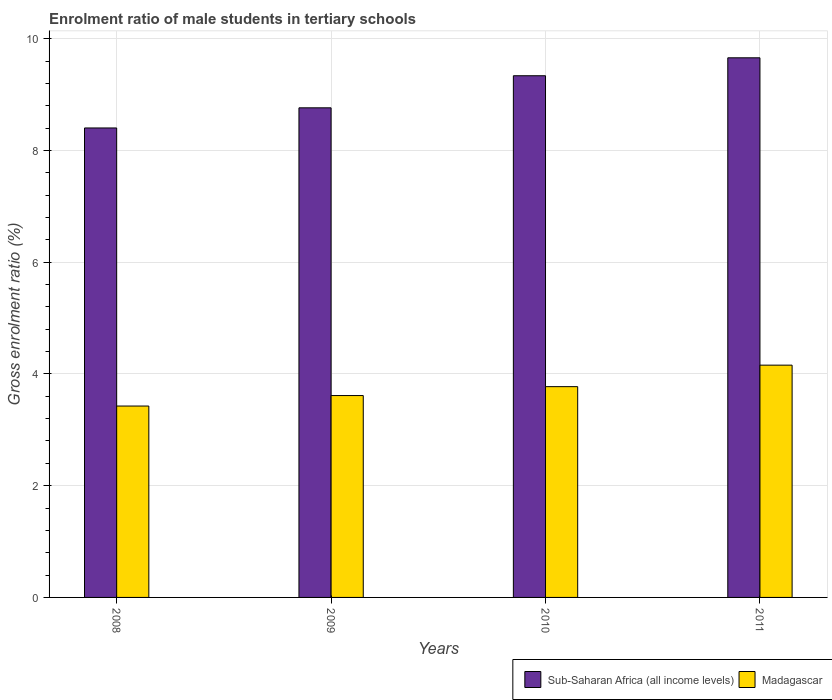How many groups of bars are there?
Your response must be concise. 4. Are the number of bars per tick equal to the number of legend labels?
Your answer should be compact. Yes. How many bars are there on the 1st tick from the right?
Your answer should be very brief. 2. What is the label of the 3rd group of bars from the left?
Keep it short and to the point. 2010. What is the enrolment ratio of male students in tertiary schools in Sub-Saharan Africa (all income levels) in 2009?
Provide a succinct answer. 8.76. Across all years, what is the maximum enrolment ratio of male students in tertiary schools in Sub-Saharan Africa (all income levels)?
Give a very brief answer. 9.66. Across all years, what is the minimum enrolment ratio of male students in tertiary schools in Madagascar?
Provide a short and direct response. 3.43. What is the total enrolment ratio of male students in tertiary schools in Sub-Saharan Africa (all income levels) in the graph?
Your answer should be compact. 36.16. What is the difference between the enrolment ratio of male students in tertiary schools in Madagascar in 2008 and that in 2009?
Ensure brevity in your answer.  -0.19. What is the difference between the enrolment ratio of male students in tertiary schools in Madagascar in 2008 and the enrolment ratio of male students in tertiary schools in Sub-Saharan Africa (all income levels) in 2009?
Your response must be concise. -5.34. What is the average enrolment ratio of male students in tertiary schools in Sub-Saharan Africa (all income levels) per year?
Ensure brevity in your answer.  9.04. In the year 2009, what is the difference between the enrolment ratio of male students in tertiary schools in Sub-Saharan Africa (all income levels) and enrolment ratio of male students in tertiary schools in Madagascar?
Your response must be concise. 5.15. In how many years, is the enrolment ratio of male students in tertiary schools in Madagascar greater than 2 %?
Ensure brevity in your answer.  4. What is the ratio of the enrolment ratio of male students in tertiary schools in Sub-Saharan Africa (all income levels) in 2009 to that in 2010?
Make the answer very short. 0.94. Is the enrolment ratio of male students in tertiary schools in Madagascar in 2008 less than that in 2011?
Give a very brief answer. Yes. What is the difference between the highest and the second highest enrolment ratio of male students in tertiary schools in Madagascar?
Provide a succinct answer. 0.38. What is the difference between the highest and the lowest enrolment ratio of male students in tertiary schools in Madagascar?
Provide a succinct answer. 0.73. In how many years, is the enrolment ratio of male students in tertiary schools in Sub-Saharan Africa (all income levels) greater than the average enrolment ratio of male students in tertiary schools in Sub-Saharan Africa (all income levels) taken over all years?
Provide a succinct answer. 2. What does the 2nd bar from the left in 2011 represents?
Ensure brevity in your answer.  Madagascar. What does the 2nd bar from the right in 2011 represents?
Your answer should be very brief. Sub-Saharan Africa (all income levels). How many years are there in the graph?
Your answer should be compact. 4. What is the difference between two consecutive major ticks on the Y-axis?
Ensure brevity in your answer.  2. Are the values on the major ticks of Y-axis written in scientific E-notation?
Keep it short and to the point. No. Does the graph contain any zero values?
Keep it short and to the point. No. How are the legend labels stacked?
Ensure brevity in your answer.  Horizontal. What is the title of the graph?
Provide a succinct answer. Enrolment ratio of male students in tertiary schools. What is the label or title of the X-axis?
Offer a very short reply. Years. What is the Gross enrolment ratio (%) in Sub-Saharan Africa (all income levels) in 2008?
Your answer should be very brief. 8.4. What is the Gross enrolment ratio (%) of Madagascar in 2008?
Provide a succinct answer. 3.43. What is the Gross enrolment ratio (%) in Sub-Saharan Africa (all income levels) in 2009?
Your answer should be very brief. 8.76. What is the Gross enrolment ratio (%) in Madagascar in 2009?
Provide a short and direct response. 3.61. What is the Gross enrolment ratio (%) in Sub-Saharan Africa (all income levels) in 2010?
Ensure brevity in your answer.  9.34. What is the Gross enrolment ratio (%) of Madagascar in 2010?
Give a very brief answer. 3.77. What is the Gross enrolment ratio (%) of Sub-Saharan Africa (all income levels) in 2011?
Your answer should be very brief. 9.66. What is the Gross enrolment ratio (%) of Madagascar in 2011?
Offer a very short reply. 4.16. Across all years, what is the maximum Gross enrolment ratio (%) of Sub-Saharan Africa (all income levels)?
Your answer should be very brief. 9.66. Across all years, what is the maximum Gross enrolment ratio (%) of Madagascar?
Your answer should be compact. 4.16. Across all years, what is the minimum Gross enrolment ratio (%) in Sub-Saharan Africa (all income levels)?
Offer a terse response. 8.4. Across all years, what is the minimum Gross enrolment ratio (%) of Madagascar?
Offer a very short reply. 3.43. What is the total Gross enrolment ratio (%) in Sub-Saharan Africa (all income levels) in the graph?
Your answer should be very brief. 36.16. What is the total Gross enrolment ratio (%) in Madagascar in the graph?
Offer a very short reply. 14.97. What is the difference between the Gross enrolment ratio (%) in Sub-Saharan Africa (all income levels) in 2008 and that in 2009?
Provide a succinct answer. -0.36. What is the difference between the Gross enrolment ratio (%) in Madagascar in 2008 and that in 2009?
Give a very brief answer. -0.19. What is the difference between the Gross enrolment ratio (%) of Sub-Saharan Africa (all income levels) in 2008 and that in 2010?
Make the answer very short. -0.93. What is the difference between the Gross enrolment ratio (%) of Madagascar in 2008 and that in 2010?
Provide a succinct answer. -0.35. What is the difference between the Gross enrolment ratio (%) of Sub-Saharan Africa (all income levels) in 2008 and that in 2011?
Provide a short and direct response. -1.26. What is the difference between the Gross enrolment ratio (%) in Madagascar in 2008 and that in 2011?
Give a very brief answer. -0.73. What is the difference between the Gross enrolment ratio (%) of Sub-Saharan Africa (all income levels) in 2009 and that in 2010?
Keep it short and to the point. -0.57. What is the difference between the Gross enrolment ratio (%) of Madagascar in 2009 and that in 2010?
Give a very brief answer. -0.16. What is the difference between the Gross enrolment ratio (%) of Sub-Saharan Africa (all income levels) in 2009 and that in 2011?
Provide a succinct answer. -0.9. What is the difference between the Gross enrolment ratio (%) of Madagascar in 2009 and that in 2011?
Provide a short and direct response. -0.54. What is the difference between the Gross enrolment ratio (%) in Sub-Saharan Africa (all income levels) in 2010 and that in 2011?
Offer a terse response. -0.32. What is the difference between the Gross enrolment ratio (%) of Madagascar in 2010 and that in 2011?
Provide a succinct answer. -0.38. What is the difference between the Gross enrolment ratio (%) in Sub-Saharan Africa (all income levels) in 2008 and the Gross enrolment ratio (%) in Madagascar in 2009?
Make the answer very short. 4.79. What is the difference between the Gross enrolment ratio (%) of Sub-Saharan Africa (all income levels) in 2008 and the Gross enrolment ratio (%) of Madagascar in 2010?
Make the answer very short. 4.63. What is the difference between the Gross enrolment ratio (%) of Sub-Saharan Africa (all income levels) in 2008 and the Gross enrolment ratio (%) of Madagascar in 2011?
Offer a very short reply. 4.25. What is the difference between the Gross enrolment ratio (%) in Sub-Saharan Africa (all income levels) in 2009 and the Gross enrolment ratio (%) in Madagascar in 2010?
Your answer should be very brief. 4.99. What is the difference between the Gross enrolment ratio (%) of Sub-Saharan Africa (all income levels) in 2009 and the Gross enrolment ratio (%) of Madagascar in 2011?
Offer a very short reply. 4.61. What is the difference between the Gross enrolment ratio (%) of Sub-Saharan Africa (all income levels) in 2010 and the Gross enrolment ratio (%) of Madagascar in 2011?
Ensure brevity in your answer.  5.18. What is the average Gross enrolment ratio (%) of Sub-Saharan Africa (all income levels) per year?
Offer a terse response. 9.04. What is the average Gross enrolment ratio (%) of Madagascar per year?
Give a very brief answer. 3.74. In the year 2008, what is the difference between the Gross enrolment ratio (%) of Sub-Saharan Africa (all income levels) and Gross enrolment ratio (%) of Madagascar?
Your answer should be compact. 4.98. In the year 2009, what is the difference between the Gross enrolment ratio (%) of Sub-Saharan Africa (all income levels) and Gross enrolment ratio (%) of Madagascar?
Provide a succinct answer. 5.15. In the year 2010, what is the difference between the Gross enrolment ratio (%) in Sub-Saharan Africa (all income levels) and Gross enrolment ratio (%) in Madagascar?
Provide a succinct answer. 5.56. In the year 2011, what is the difference between the Gross enrolment ratio (%) of Sub-Saharan Africa (all income levels) and Gross enrolment ratio (%) of Madagascar?
Offer a terse response. 5.5. What is the ratio of the Gross enrolment ratio (%) in Sub-Saharan Africa (all income levels) in 2008 to that in 2009?
Offer a terse response. 0.96. What is the ratio of the Gross enrolment ratio (%) in Madagascar in 2008 to that in 2009?
Offer a very short reply. 0.95. What is the ratio of the Gross enrolment ratio (%) in Sub-Saharan Africa (all income levels) in 2008 to that in 2010?
Make the answer very short. 0.9. What is the ratio of the Gross enrolment ratio (%) in Madagascar in 2008 to that in 2010?
Provide a short and direct response. 0.91. What is the ratio of the Gross enrolment ratio (%) of Sub-Saharan Africa (all income levels) in 2008 to that in 2011?
Give a very brief answer. 0.87. What is the ratio of the Gross enrolment ratio (%) of Madagascar in 2008 to that in 2011?
Your response must be concise. 0.82. What is the ratio of the Gross enrolment ratio (%) of Sub-Saharan Africa (all income levels) in 2009 to that in 2010?
Your answer should be very brief. 0.94. What is the ratio of the Gross enrolment ratio (%) in Madagascar in 2009 to that in 2010?
Keep it short and to the point. 0.96. What is the ratio of the Gross enrolment ratio (%) in Sub-Saharan Africa (all income levels) in 2009 to that in 2011?
Your response must be concise. 0.91. What is the ratio of the Gross enrolment ratio (%) in Madagascar in 2009 to that in 2011?
Ensure brevity in your answer.  0.87. What is the ratio of the Gross enrolment ratio (%) of Sub-Saharan Africa (all income levels) in 2010 to that in 2011?
Give a very brief answer. 0.97. What is the ratio of the Gross enrolment ratio (%) in Madagascar in 2010 to that in 2011?
Keep it short and to the point. 0.91. What is the difference between the highest and the second highest Gross enrolment ratio (%) of Sub-Saharan Africa (all income levels)?
Your response must be concise. 0.32. What is the difference between the highest and the second highest Gross enrolment ratio (%) in Madagascar?
Your answer should be compact. 0.38. What is the difference between the highest and the lowest Gross enrolment ratio (%) of Sub-Saharan Africa (all income levels)?
Provide a short and direct response. 1.26. What is the difference between the highest and the lowest Gross enrolment ratio (%) in Madagascar?
Offer a very short reply. 0.73. 